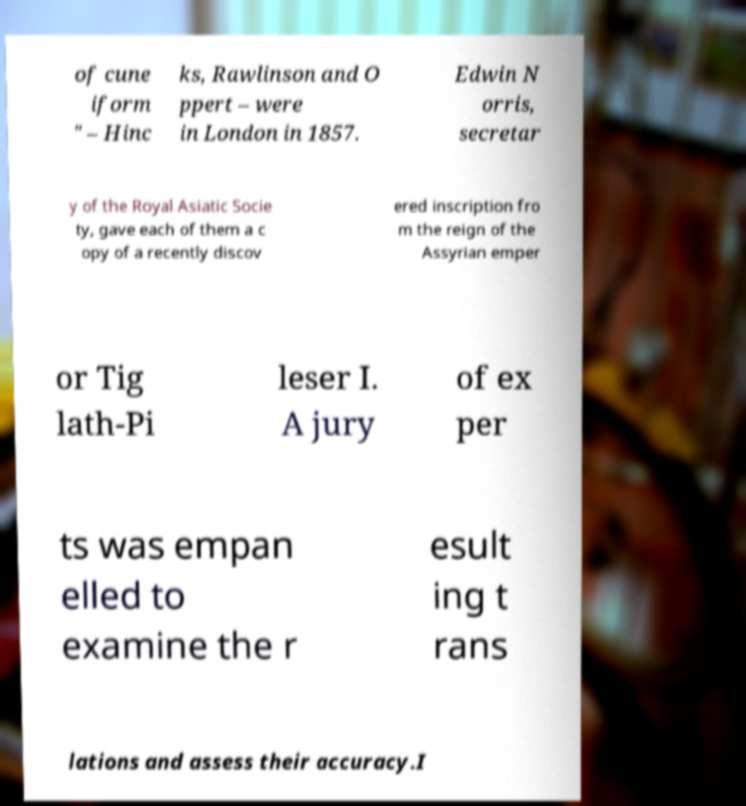Can you read and provide the text displayed in the image?This photo seems to have some interesting text. Can you extract and type it out for me? of cune iform " – Hinc ks, Rawlinson and O ppert – were in London in 1857. Edwin N orris, secretar y of the Royal Asiatic Socie ty, gave each of them a c opy of a recently discov ered inscription fro m the reign of the Assyrian emper or Tig lath-Pi leser I. A jury of ex per ts was empan elled to examine the r esult ing t rans lations and assess their accuracy.I 